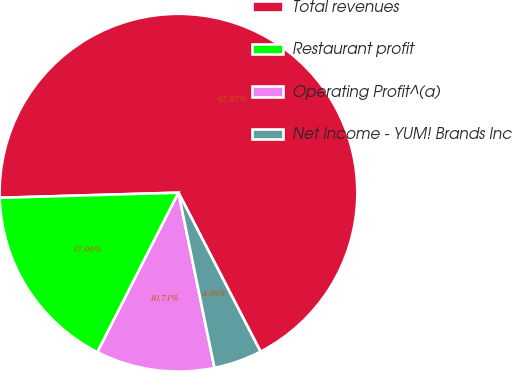Convert chart to OTSL. <chart><loc_0><loc_0><loc_500><loc_500><pie_chart><fcel>Total revenues<fcel>Restaurant profit<fcel>Operating Profit^(a)<fcel>Net Income - YUM! Brands Inc<nl><fcel>67.87%<fcel>17.06%<fcel>10.71%<fcel>4.36%<nl></chart> 